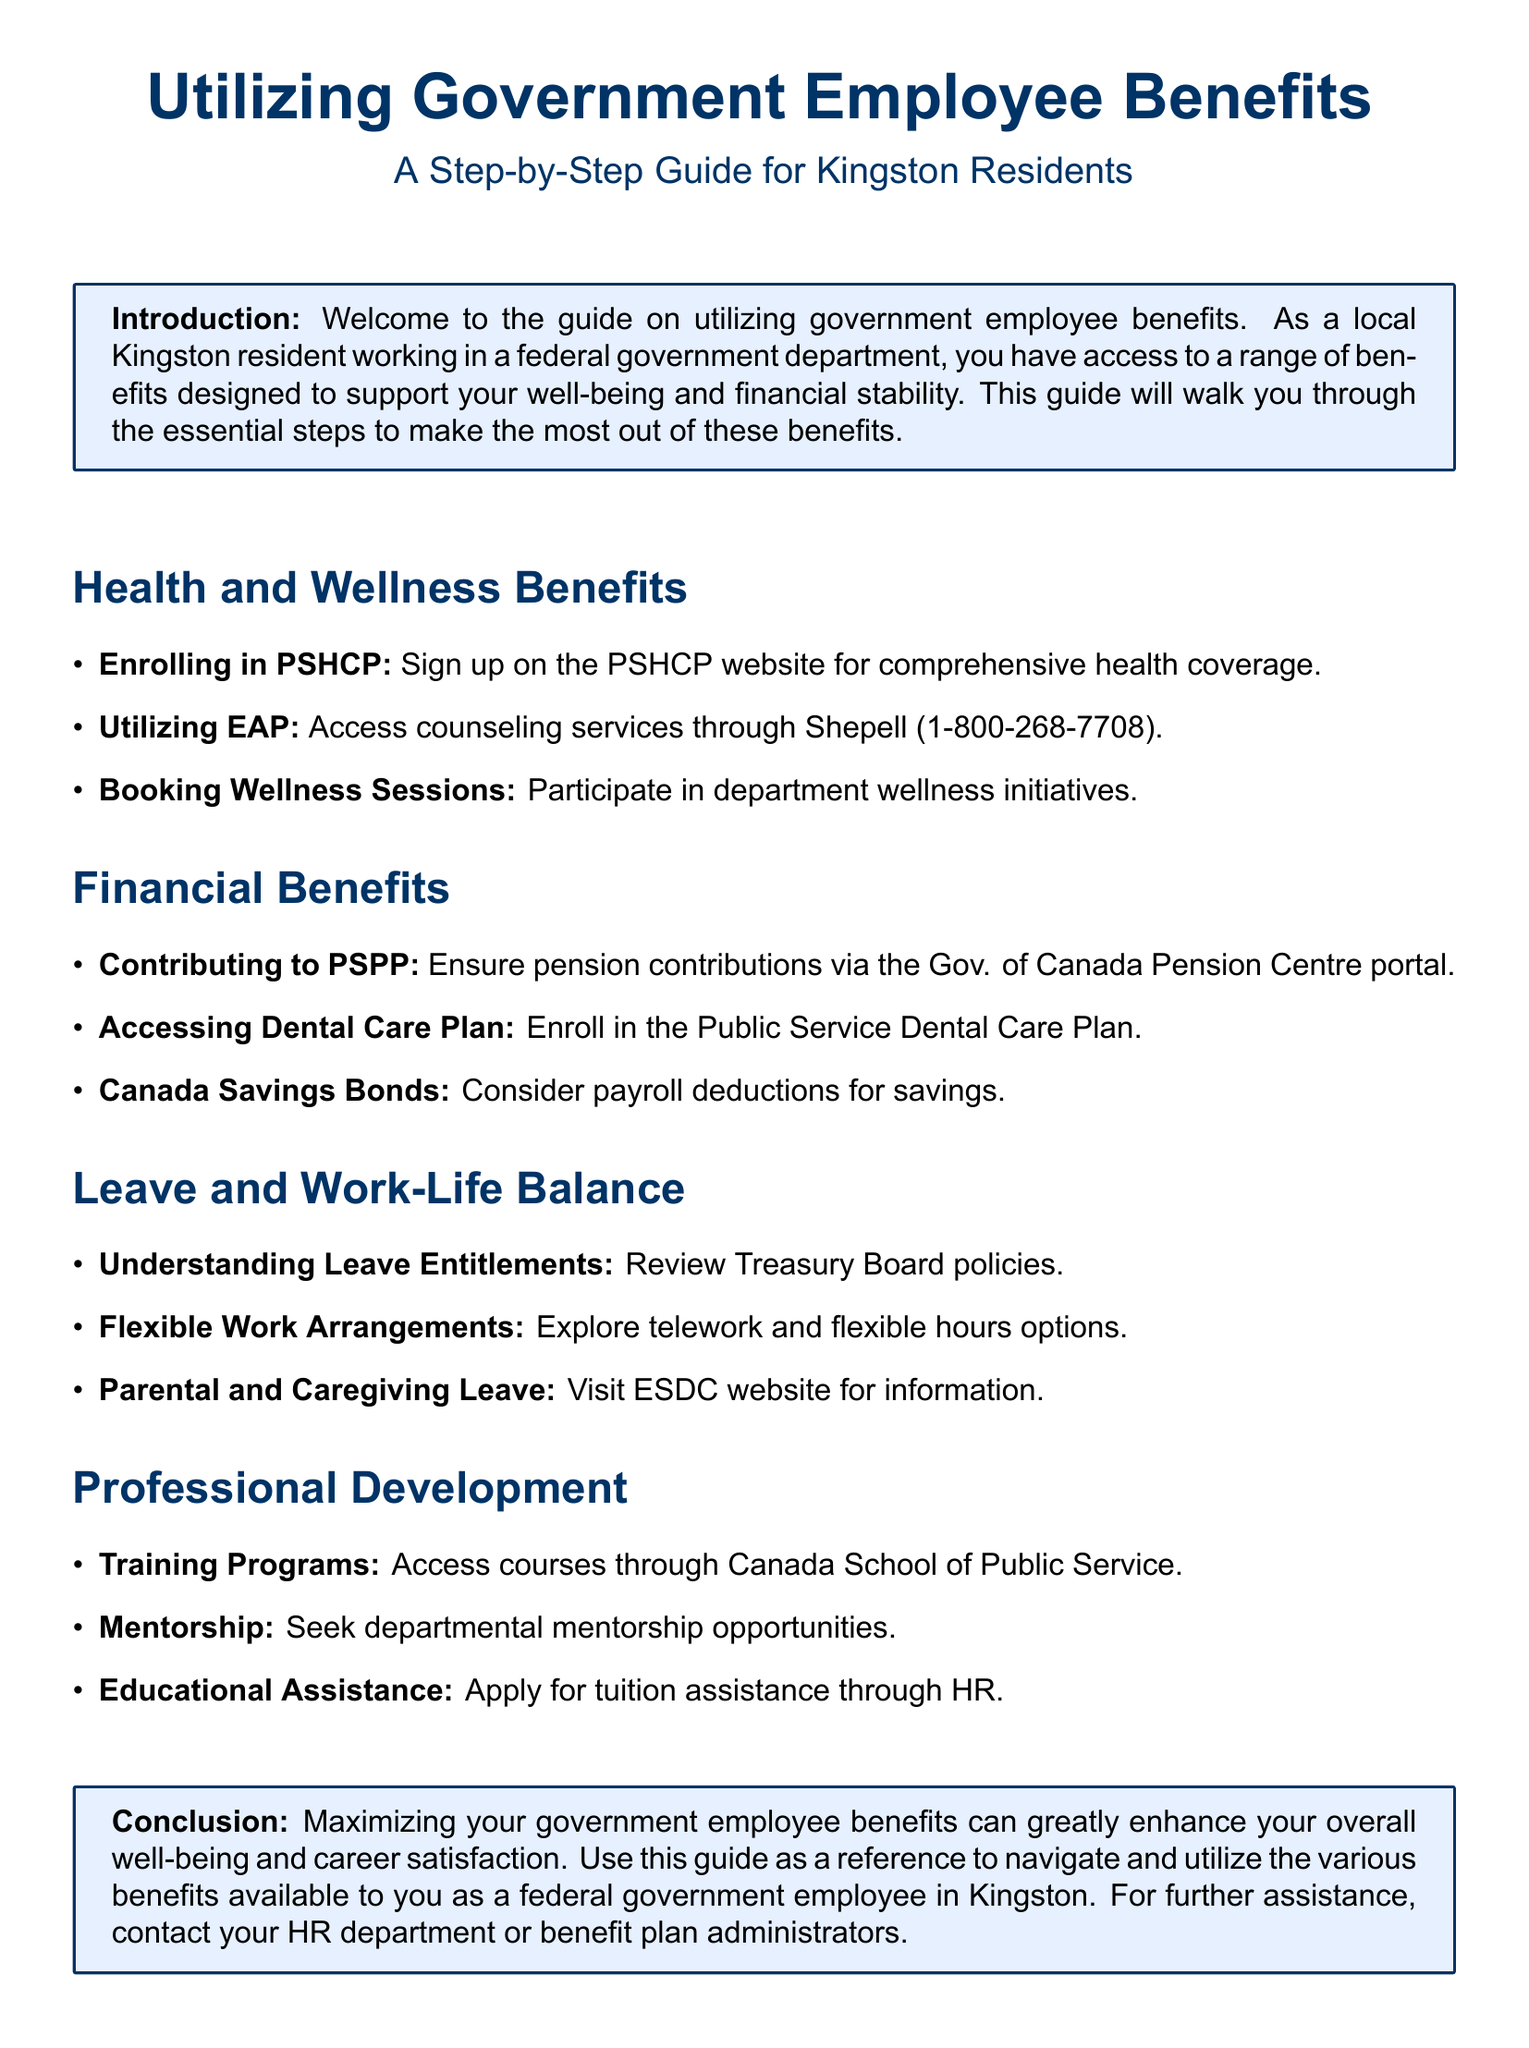What does PSHCP stand for? PSHCP stands for Public Service Health Care Plan, which is mentioned in the Health and Wellness Benefits section.
Answer: Public Service Health Care Plan What is the phone number for accessing EAP? The Employee Assistance Program (EAP) can be accessed by calling Shepell at the specified phone number in the document.
Answer: 1-800-268-7708 What is the website to visit for parental and caregiving leave information? The document directs readers to visit the ESDC website for information on parental and caregiving leave.
Answer: ESDC website Which program allows for pension contributions? PSPP is referred to in the Financial Benefits section as the program for ensuring pension contributions.
Answer: PSPP Where can you apply for tuition assistance? The guide indicates that educational assistance applications can be made through HR for those seeking tuition support.
Answer: HR What type of leave is mentioned for working parents? The document specifically mentions parental leave in the Leave and Work-Life Balance section as a benefit for working parents.
Answer: Parental leave Which organization offers training programs for federal employees? The Canada School of Public Service is highlighted in the Professional Development section as the provider of training programs.
Answer: Canada School of Public Service What should you contact for further assistance? The document suggests contacting HR department or benefit plan administrators for further assistance regarding employee benefits.
Answer: HR department or benefit plan administrators What is the overall purpose of this guide? The guide aims to help Kingston residents maximize their government employee benefits, enhancing well-being and career satisfaction.
Answer: Maximizing government employee benefits 